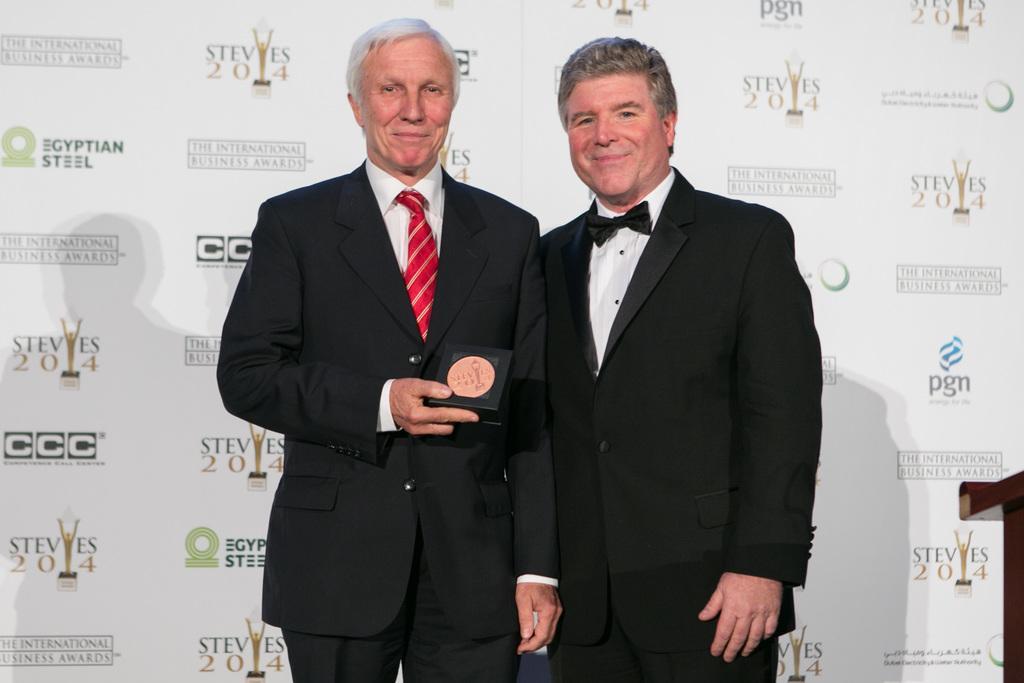Could you give a brief overview of what you see in this image? In the image we can see there are two men standing and they are wearing formal suit. A man is holding a box in his hand and behind there is a banner. 